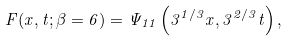<formula> <loc_0><loc_0><loc_500><loc_500>F ( x , t ; \beta = 6 ) = \Psi _ { 1 1 } \left ( 3 ^ { 1 / 3 } x , 3 ^ { 2 / 3 } t \right ) ,</formula> 